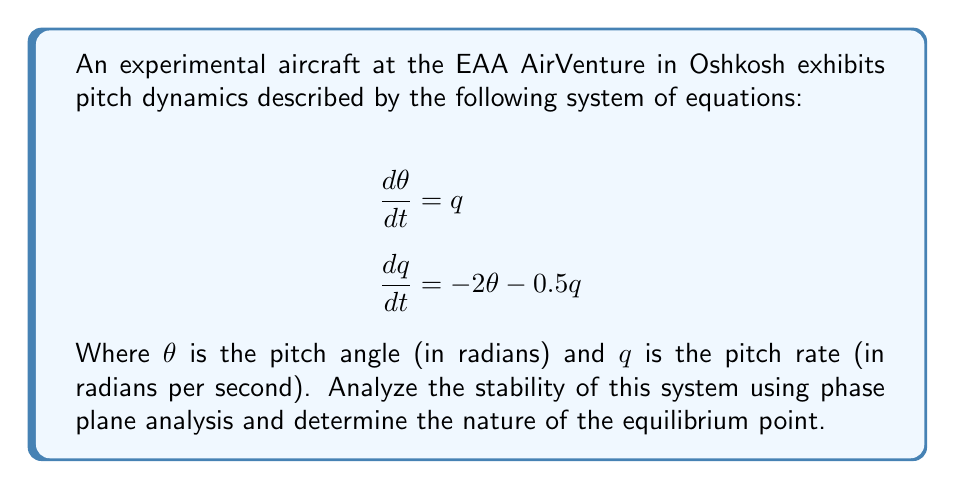What is the answer to this math problem? 1. Identify the equilibrium point:
   Set $\frac{d\theta}{dt} = 0$ and $\frac{dq}{dt} = 0$:
   $q = 0$
   $-2\theta - 0.5q = 0$
   Solving these equations, we get $(\theta, q) = (0, 0)$

2. Linearize the system around the equilibrium point:
   The system is already linear, so no linearization is needed.

3. Write the system in matrix form:
   $$\begin{bmatrix} \frac{d\theta}{dt} \\ \frac{dq}{dt} \end{bmatrix} = \begin{bmatrix} 0 & 1 \\ -2 & -0.5 \end{bmatrix} \begin{bmatrix} \theta \\ q \end{bmatrix}$$

4. Find the eigenvalues of the system matrix:
   $\det(\lambda I - A) = \det\begin{bmatrix} \lambda & -1 \\ 2 & \lambda + 0.5 \end{bmatrix} = 0$
   $\lambda^2 + 0.5\lambda + 2 = 0$
   $\lambda = \frac{-0.5 \pm \sqrt{0.25 - 8}}{2} = -0.25 \pm 1.3919i$

5. Analyze the eigenvalues:
   The real part of both eigenvalues is negative (-0.25), and there is a non-zero imaginary part.

6. Sketch the phase portrait:
   [asy]
   import graph;
   size(200);
   xaxis("θ", Arrow);
   yaxis("q", Arrow);
   path spiral = (1,0){dir(70)}..(-0.5,0.87)..(-0.87,-0.5)..(0,-1)..(0.87,0.5)..(0.5,-0.87)..cycle;
   draw(spiral, Arrow);
   draw(reflect(O,N)*spiral, Arrow);
   dot((0,0));
   label("(0,0)", (0,0), SE);
   [/asy]

7. Interpret the results:
   The negative real part indicates that the system is stable.
   The non-zero imaginary part indicates oscillatory behavior.
   The phase portrait shows a spiral sink converging to the origin.
Answer: Stable spiral sink 